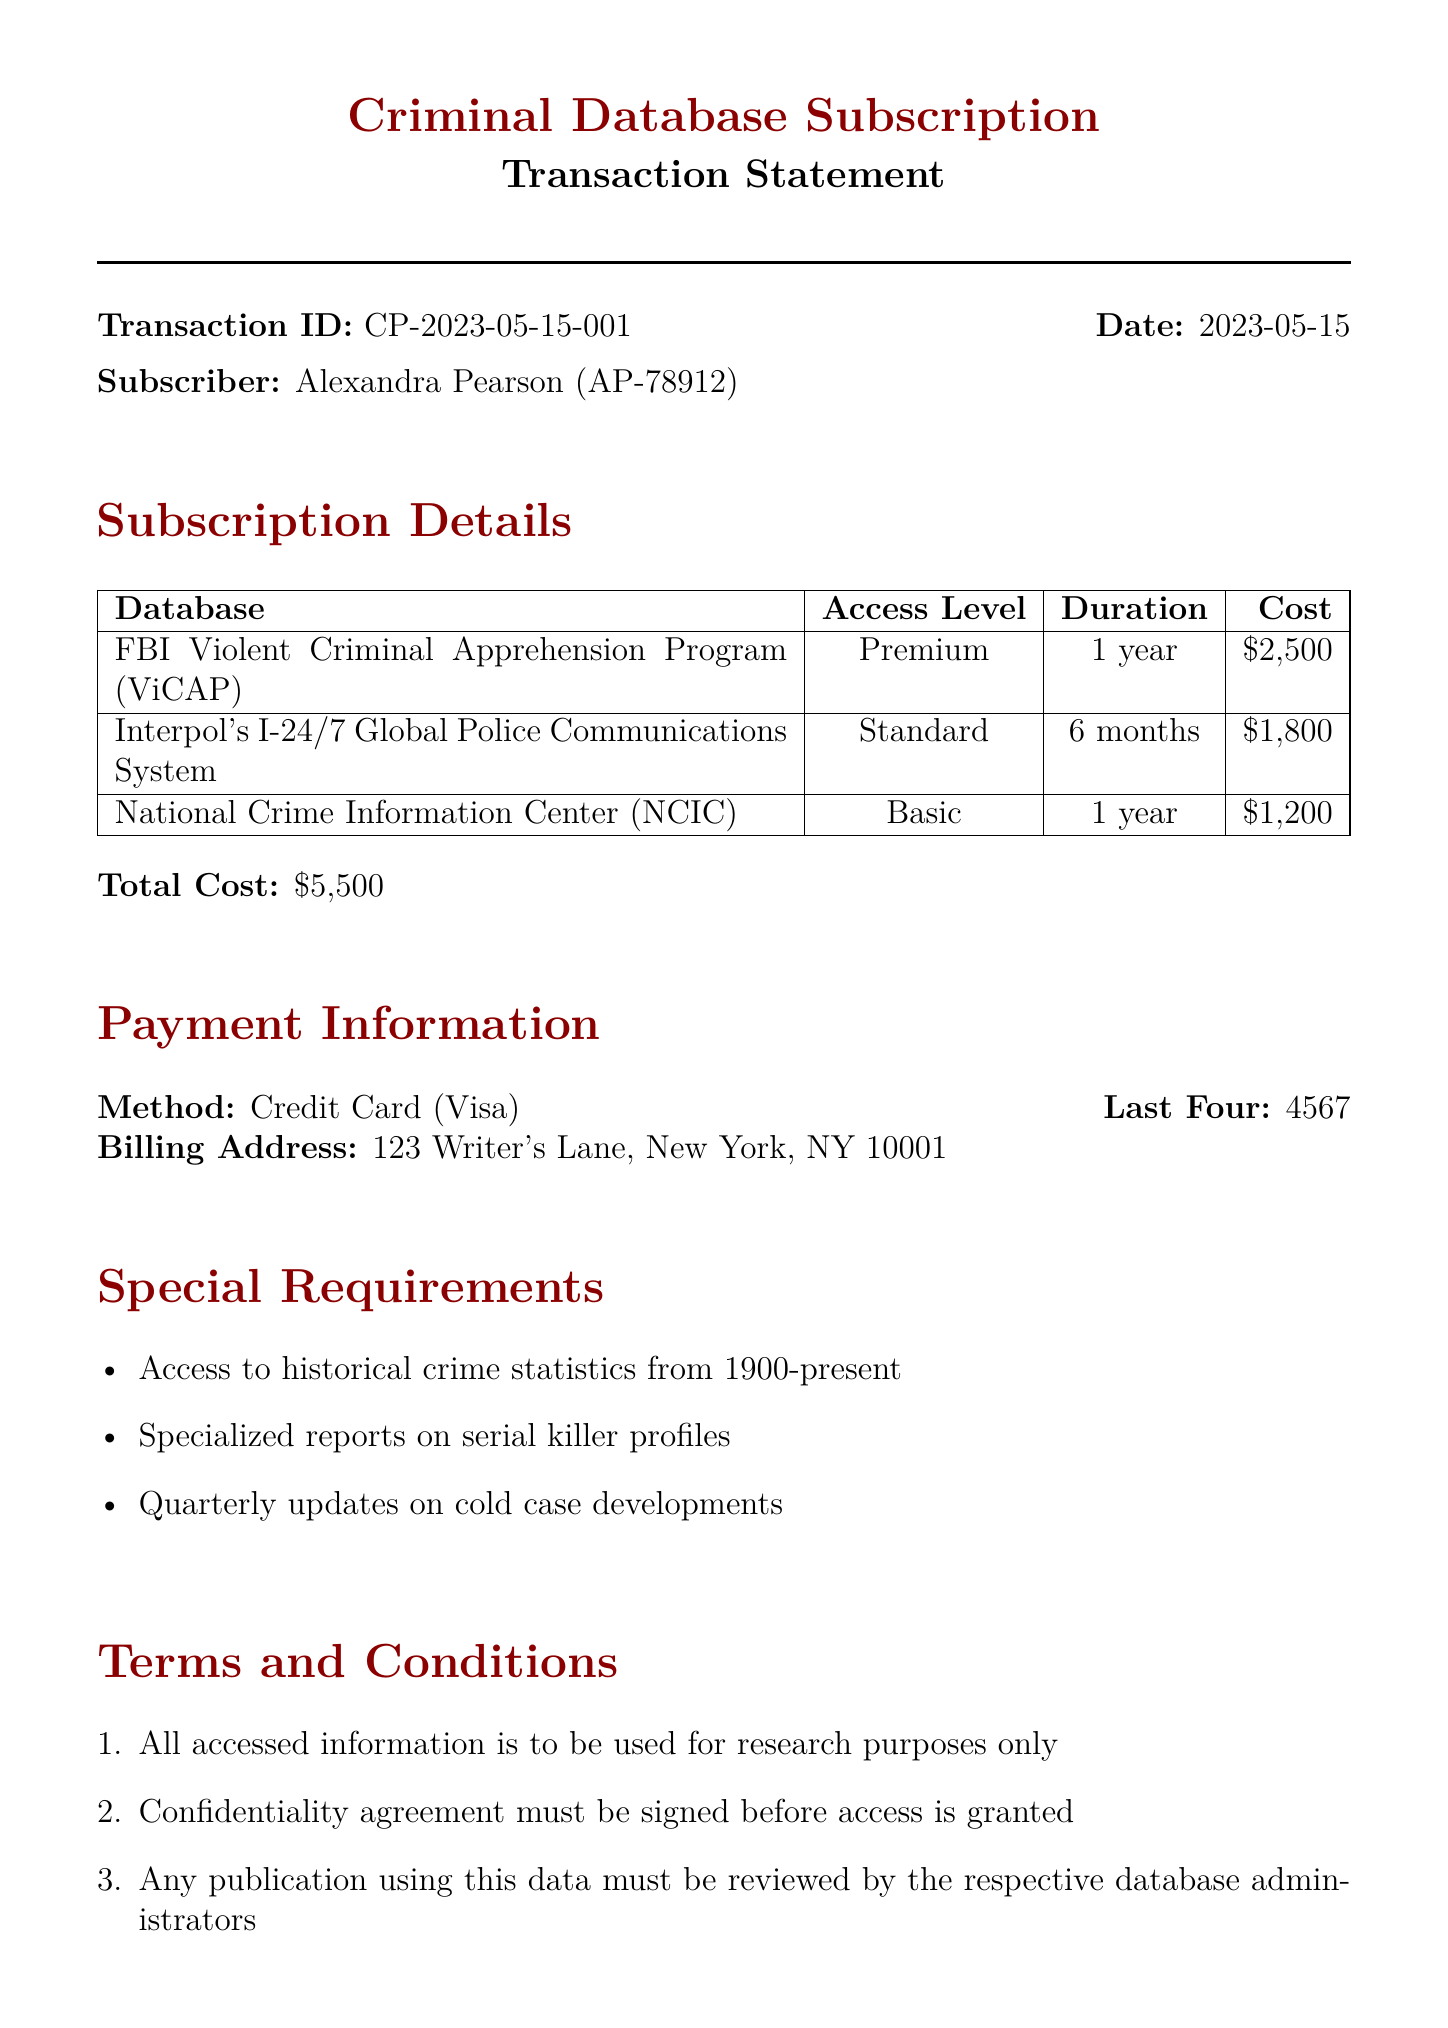What is the transaction ID? The transaction ID is a unique identifier for the transaction detailed in the document.
Answer: CP-2023-05-15-001 Who is the subscriber? The subscriber's name is mentioned at the top of the document.
Answer: Alexandra Pearson What is the total cost of the subscription? The total cost is the sum of the individual costs of the database subscriptions listed in the document.
Answer: $5,500 What is the duration of the subscription for the FBI Violent Criminal Apprehension Program? The duration indicates how long the subscriber has access to this particular database.
Answer: 1 year Who authorized the subscription? The name of the person who authorized the transaction is specified in the document.
Answer: Dr. John Douglas, Former FBI Profiler What special requirement is listed in the document? Special requirements provide additional expectations the subscriber has for the databases.
Answer: Access to historical crime statistics from 1900-present What payment method was used? The payment method explains how the subscription was paid for, as outlined in the document.
Answer: Credit Card What is the access level for Interpol's I-24/7 Global Police Communications System? The access level denotes the kind of access provided for this specific database.
Answer: Standard What is the billing address? The billing address is where the subscription charges are directed, mentioned explicitly in the document.
Answer: 123 Writer's Lane, New York, NY 10001 